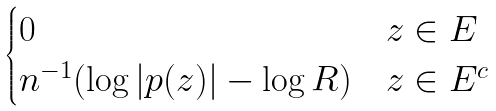Convert formula to latex. <formula><loc_0><loc_0><loc_500><loc_500>\begin{cases} 0 & z \in E \\ n ^ { - 1 } ( \log | p ( z ) | - \log R ) & z \in E ^ { c } \end{cases}</formula> 